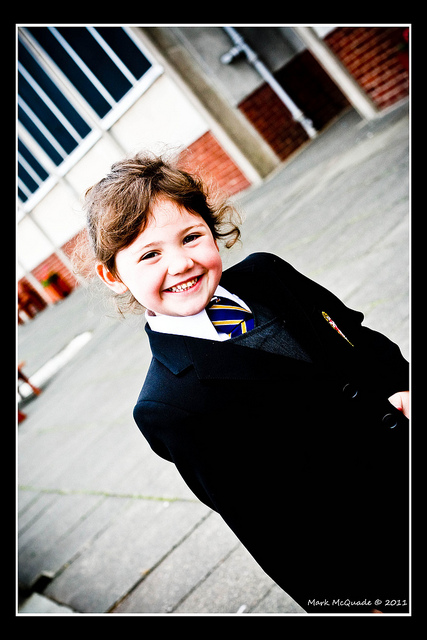Identify the text displayed in this image. Mark McQuade 2011 